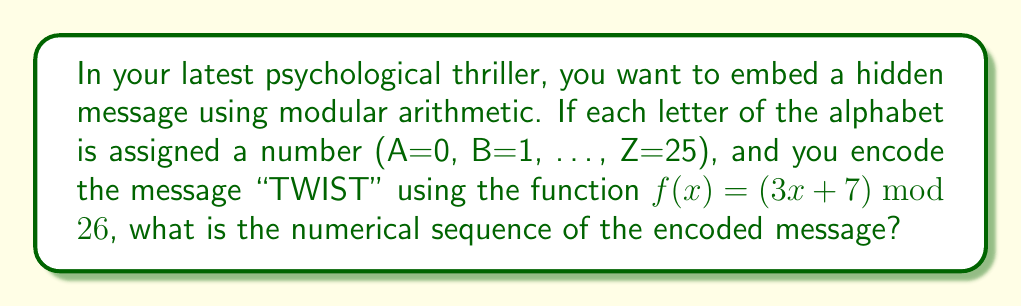Could you help me with this problem? Let's approach this step-by-step:

1) First, we need to convert "TWIST" to numbers:
   T = 19, W = 22, I = 8, S = 18, T = 19

2) Now, we apply the function $f(x) = (3x + 7) \mod 26$ to each number:

   For T (19): 
   $f(19) = (3 \cdot 19 + 7) \mod 26 = 64 \mod 26 = 12$

   For W (22):
   $f(22) = (3 \cdot 22 + 7) \mod 26 = 73 \mod 26 = 21$

   For I (8):
   $f(8) = (3 \cdot 8 + 7) \mod 26 = 31 \mod 26 = 5$

   For S (18):
   $f(18) = (3 \cdot 18 + 7) \mod 26 = 61 \mod 26 = 9$

   For T (19):
   $f(19) = (3 \cdot 19 + 7) \mod 26 = 64 \mod 26 = 12$

3) Therefore, the encoded sequence is: 12, 21, 5, 9, 12

This modular arithmetic encoding adds an extra layer of psychological complexity to your film narrative, as it transforms a simple word into a seemingly random sequence of numbers.
Answer: 12, 21, 5, 9, 12 